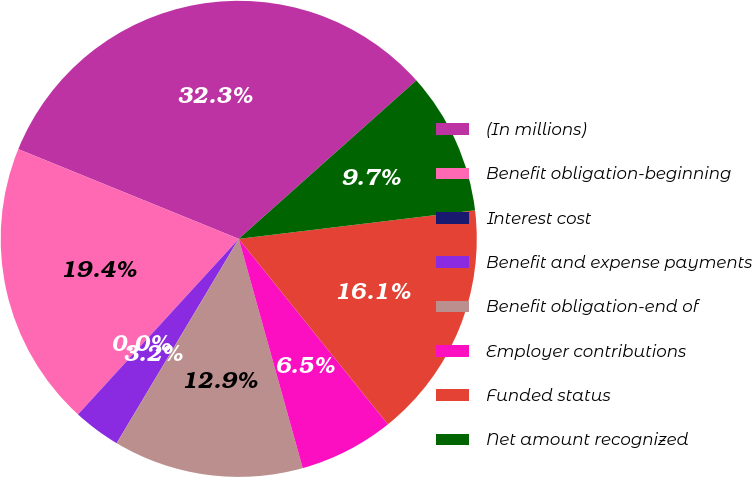Convert chart. <chart><loc_0><loc_0><loc_500><loc_500><pie_chart><fcel>(In millions)<fcel>Benefit obligation-beginning<fcel>Interest cost<fcel>Benefit and expense payments<fcel>Benefit obligation-end of<fcel>Employer contributions<fcel>Funded status<fcel>Net amount recognized<nl><fcel>32.25%<fcel>19.35%<fcel>0.0%<fcel>3.23%<fcel>12.9%<fcel>6.45%<fcel>16.13%<fcel>9.68%<nl></chart> 